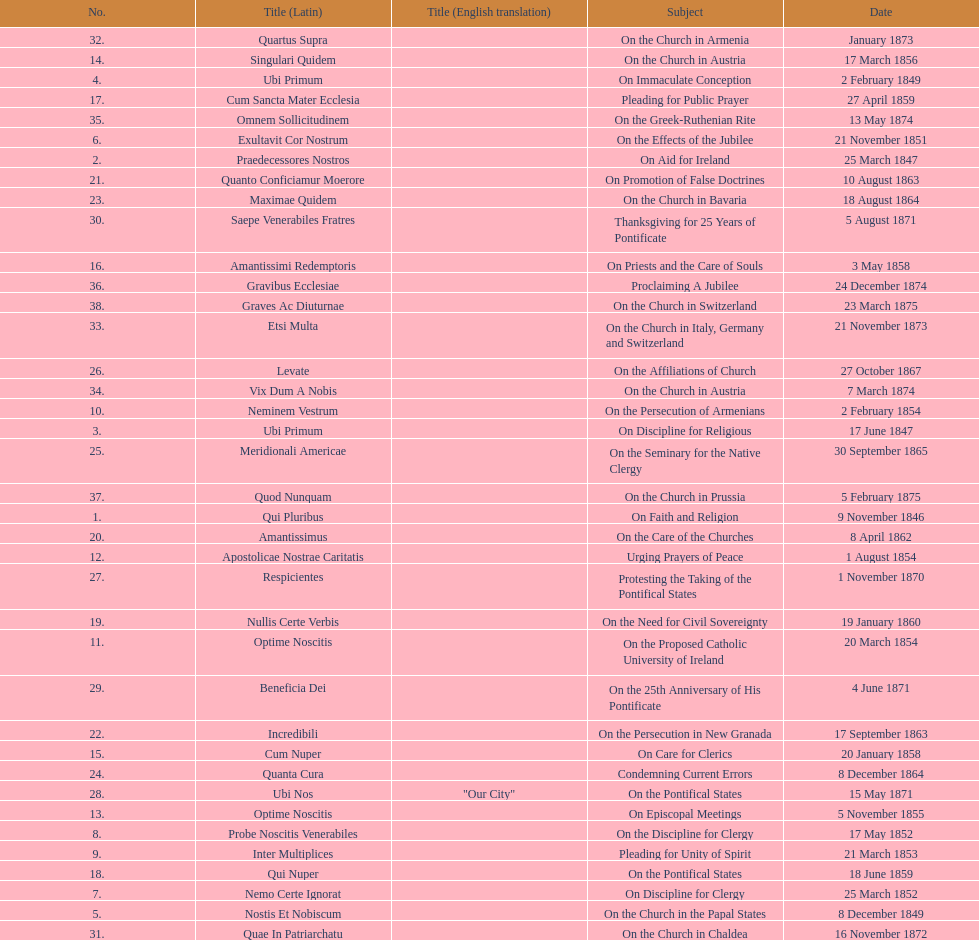What is the last title? Graves Ac Diuturnae. 